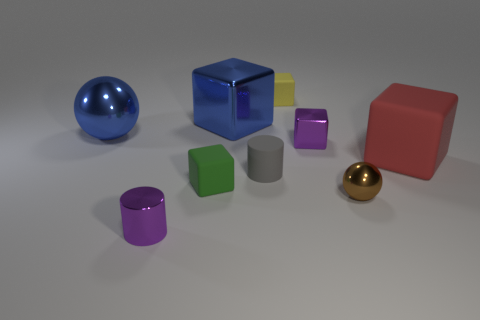Subtract all gray cubes. Subtract all yellow balls. How many cubes are left? 5 Add 1 purple cylinders. How many objects exist? 10 Subtract all balls. How many objects are left? 7 Add 1 large red metallic spheres. How many large red metallic spheres exist? 1 Subtract 0 gray spheres. How many objects are left? 9 Subtract all green shiny cylinders. Subtract all metallic balls. How many objects are left? 7 Add 3 blue metallic cubes. How many blue metallic cubes are left? 4 